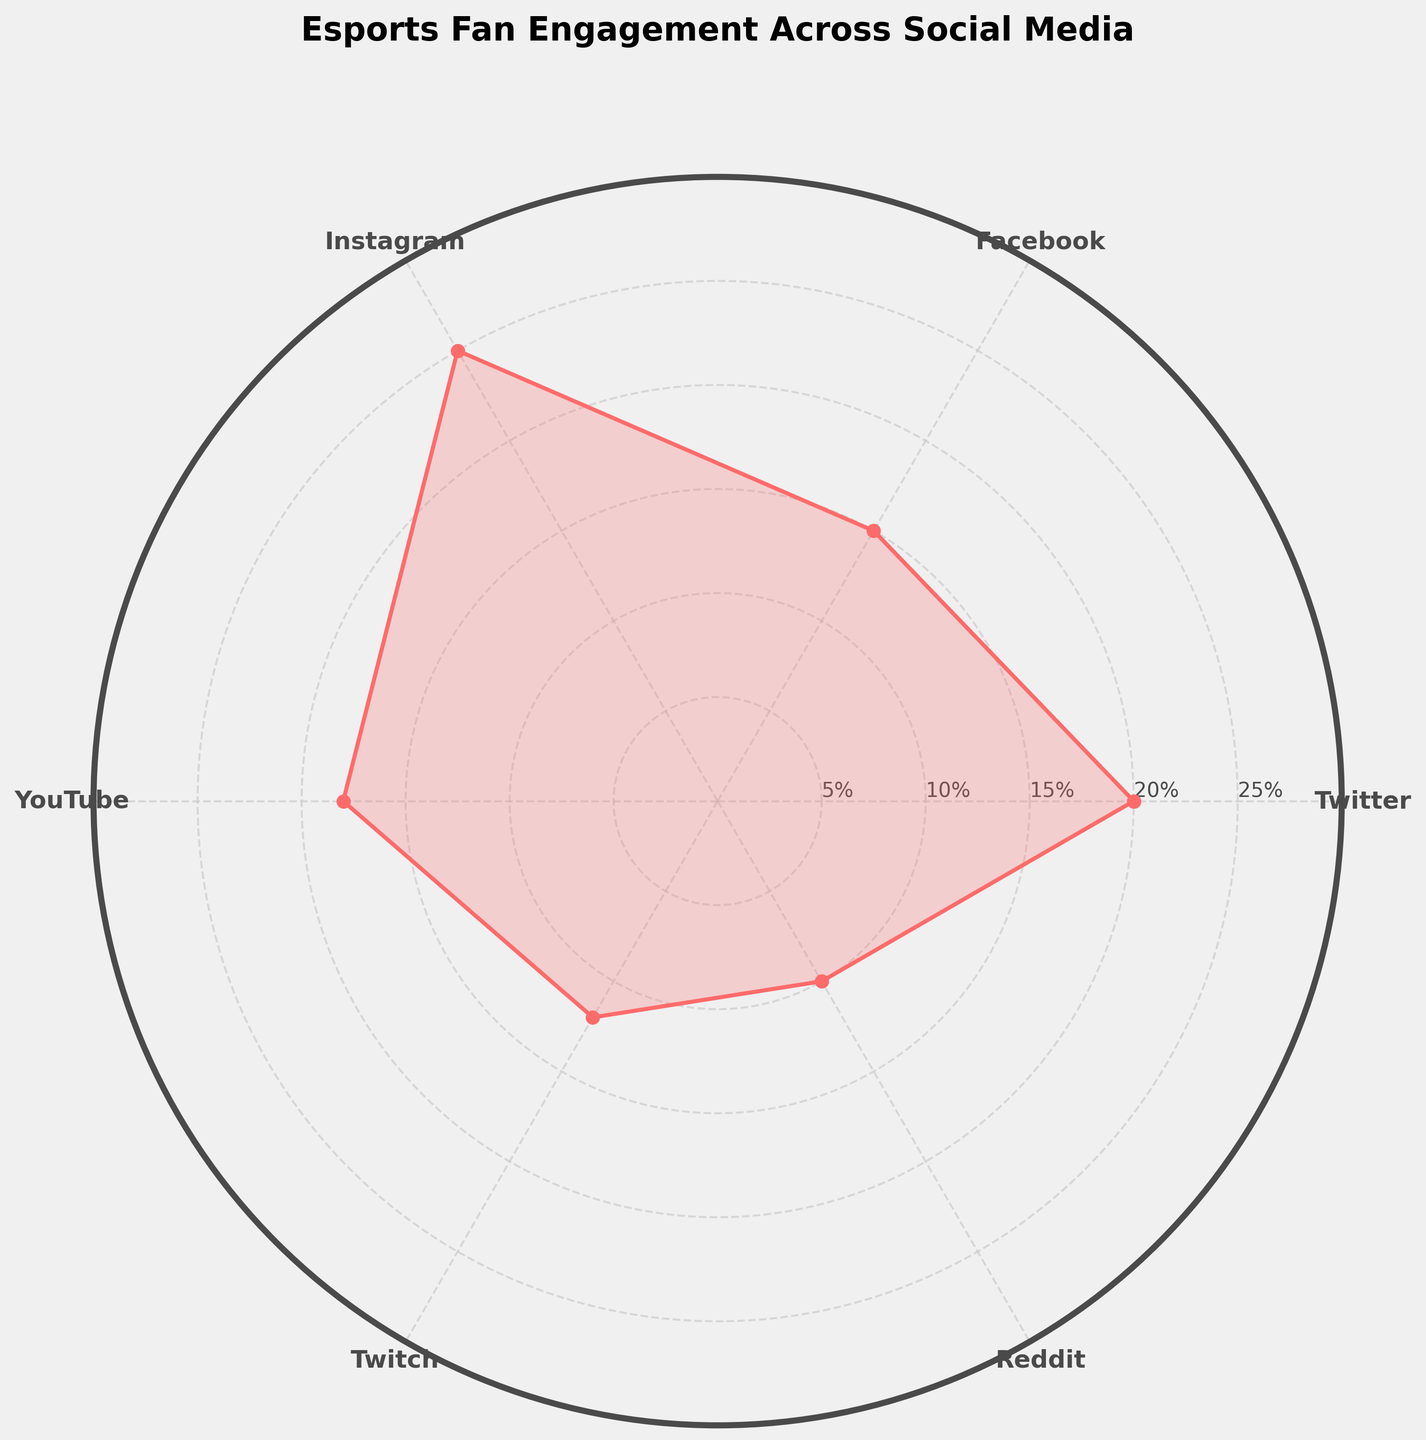What is the title of the polar chart? The title of the chart is located at the top and describes what the graph represents.
Answer: Esports Fan Engagement Across Social Media How many social media platforms are represented in the chart? The platforms are listed at each angle around the polar chart.
Answer: 6 Which platform has the highest engagement percentage? By looking at the perimeter of the chart, the highest point is on Instagram.
Answer: Instagram What is the engagement percentage for YouTube? By finding the YouTube label, trace the corresponding value on the radial line.
Answer: 18% Which platforms have engagement percentages below 15%? Platforms that are below the halfway point between 10% and 20% are considered.
Answer: Twitch, Reddit What is the difference in engagement percentage between Instagram and Reddit? Subtracting Reddit's value from Instagram's value gives the difference. 25% - 10% = 15%
Answer: 15% Compare the engagement percentage of Facebook and Twitch. Which is higher? By checking the percentage points, Facebook's value is higher than Twitch's value.
Answer: Facebook What's the sum of the engagement percentages for Twitter, Facebook, and YouTube? Sum the values of Twitter (20%), Facebook (15%), and YouTube (18%). 20% + 15% + 18% = 53%
Answer: 53% What is the average engagement percentage across all platforms? Sum all the engagement percentages and divide by the number of platforms. Total is 20% + 15% + 25% + 18% + 12% + 10% = 100%. Divide by 6: 100% / 6 ≈ 16.67%
Answer: 16.67% In the visual representation, which segment appears to be the smallest and what percentage does it represent? The smallest segment corresponds to the platform with the lowest engagement, which is traced back to Reddit.
Answer: 10% 